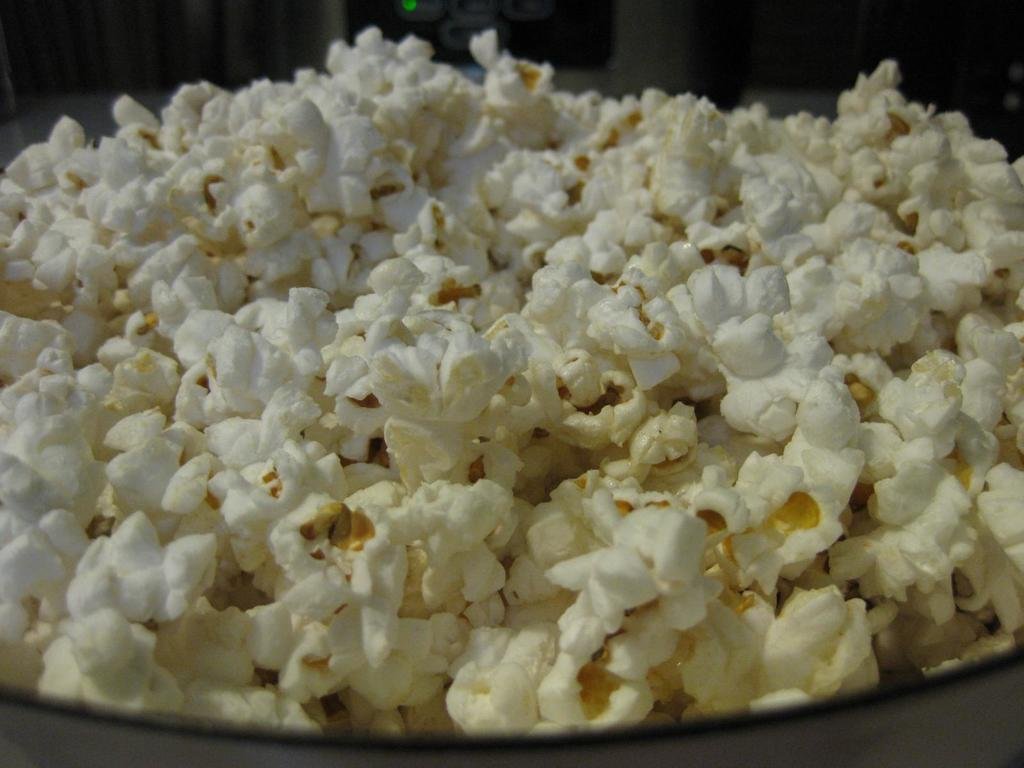What is in the bowl that is visible in the image? The bowl contains popcorn. Can you describe the contents of the bowl in more detail? The bowl contains popcorn, which is a popular snack typically enjoyed during movie nights or other events. What type of glass can be seen in the image? There is no glass present in the image; it only features a bowl containing popcorn. 